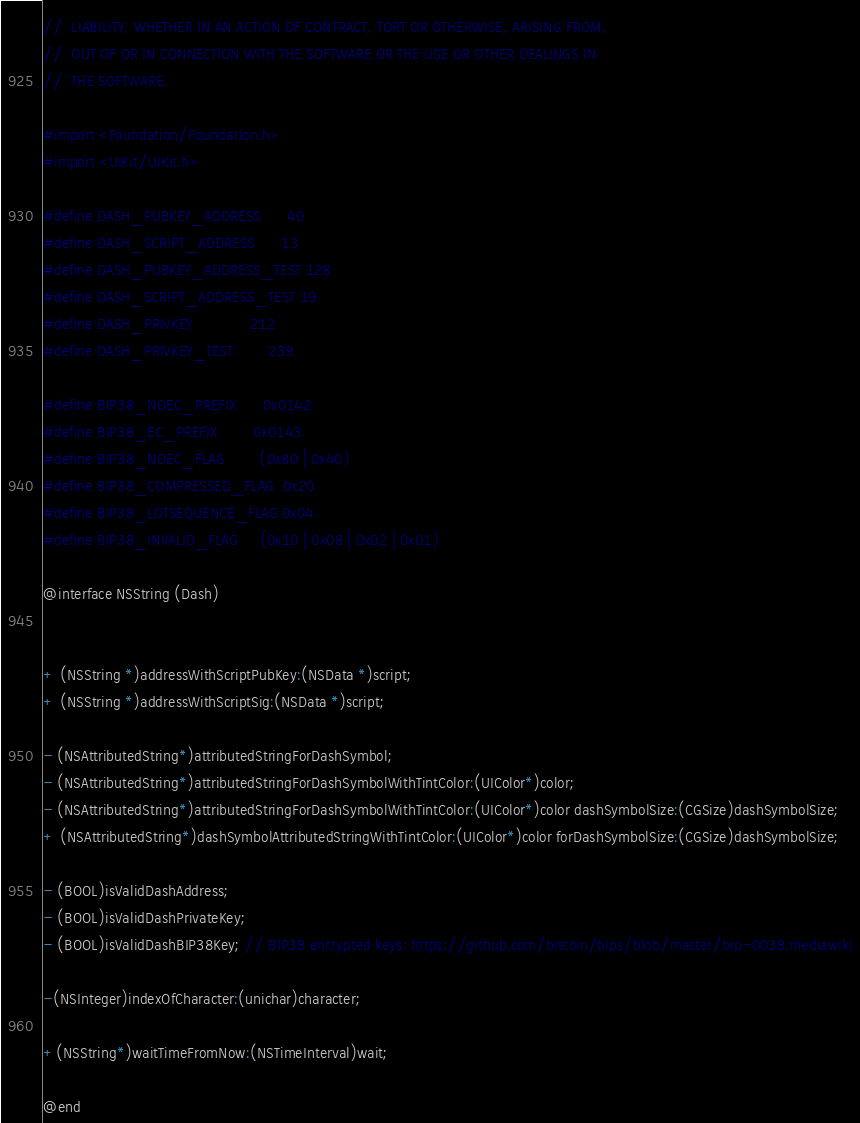Convert code to text. <code><loc_0><loc_0><loc_500><loc_500><_C_>//  LIABILITY, WHETHER IN AN ACTION OF CONTRACT, TORT OR OTHERWISE, ARISING FROM,
//  OUT OF OR IN CONNECTION WITH THE SOFTWARE OR THE USE OR OTHER DEALINGS IN
//  THE SOFTWARE.

#import <Foundation/Foundation.h>
#import <UIKit/UIKit.h>

#define DASH_PUBKEY_ADDRESS      40
#define DASH_SCRIPT_ADDRESS      13
#define DASH_PUBKEY_ADDRESS_TEST 128
#define DASH_SCRIPT_ADDRESS_TEST 19
#define DASH_PRIVKEY             212
#define DASH_PRIVKEY_TEST        239

#define BIP38_NOEC_PREFIX      0x0142
#define BIP38_EC_PREFIX        0x0143
#define BIP38_NOEC_FLAG        (0x80 | 0x40)
#define BIP38_COMPRESSED_FLAG  0x20
#define BIP38_LOTSEQUENCE_FLAG 0x04
#define BIP38_INVALID_FLAG     (0x10 | 0x08 | 0x02 | 0x01)

@interface NSString (Dash)


+ (NSString *)addressWithScriptPubKey:(NSData *)script;
+ (NSString *)addressWithScriptSig:(NSData *)script;

- (NSAttributedString*)attributedStringForDashSymbol;
- (NSAttributedString*)attributedStringForDashSymbolWithTintColor:(UIColor*)color;
- (NSAttributedString*)attributedStringForDashSymbolWithTintColor:(UIColor*)color dashSymbolSize:(CGSize)dashSymbolSize;
+ (NSAttributedString*)dashSymbolAttributedStringWithTintColor:(UIColor*)color forDashSymbolSize:(CGSize)dashSymbolSize;

- (BOOL)isValidDashAddress;
- (BOOL)isValidDashPrivateKey;
- (BOOL)isValidDashBIP38Key; // BIP38 encrypted keys: https://github.com/bitcoin/bips/blob/master/bip-0038.mediawiki

-(NSInteger)indexOfCharacter:(unichar)character;

+(NSString*)waitTimeFromNow:(NSTimeInterval)wait;

@end
</code> 